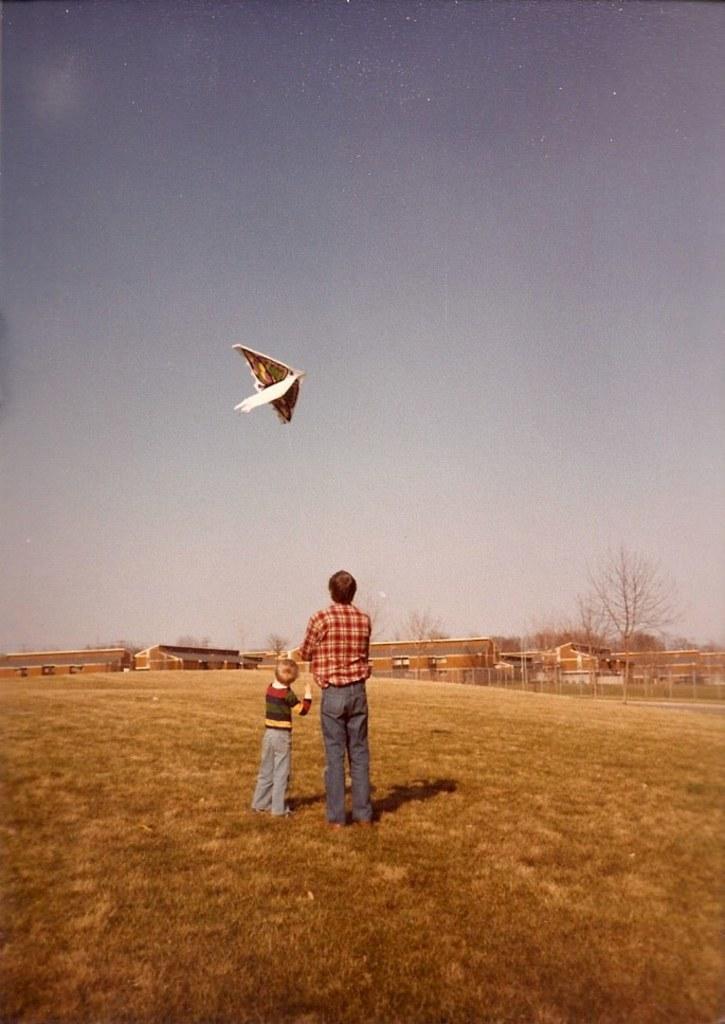Describe this image in one or two sentences. In this image we can see two persons are standing on the grass. There is an object in the air. In the background we can see buildings, trees and clouds in the sky. 